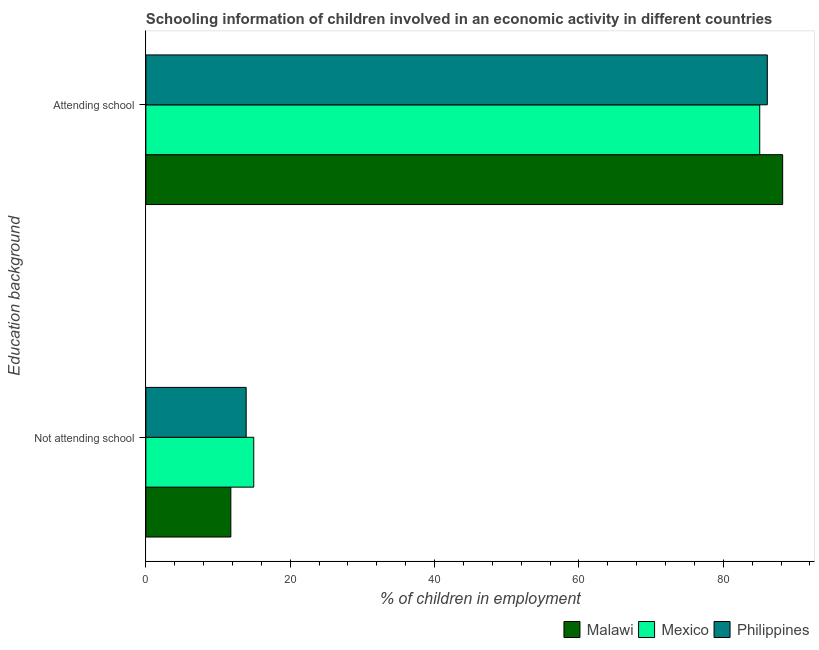How many bars are there on the 2nd tick from the bottom?
Provide a succinct answer. 3. What is the label of the 2nd group of bars from the top?
Provide a succinct answer. Not attending school. What is the percentage of employed children who are attending school in Philippines?
Your answer should be very brief. 86.1. Across all countries, what is the maximum percentage of employed children who are attending school?
Ensure brevity in your answer.  88.22. Across all countries, what is the minimum percentage of employed children who are not attending school?
Your answer should be compact. 11.78. In which country was the percentage of employed children who are attending school maximum?
Give a very brief answer. Malawi. In which country was the percentage of employed children who are not attending school minimum?
Ensure brevity in your answer.  Malawi. What is the total percentage of employed children who are not attending school in the graph?
Your response must be concise. 40.63. What is the difference between the percentage of employed children who are attending school in Philippines and that in Mexico?
Ensure brevity in your answer.  1.05. What is the difference between the percentage of employed children who are not attending school in Mexico and the percentage of employed children who are attending school in Malawi?
Offer a very short reply. -73.27. What is the average percentage of employed children who are attending school per country?
Your response must be concise. 86.46. What is the difference between the percentage of employed children who are attending school and percentage of employed children who are not attending school in Mexico?
Offer a very short reply. 70.1. In how many countries, is the percentage of employed children who are attending school greater than 56 %?
Provide a succinct answer. 3. What is the ratio of the percentage of employed children who are attending school in Malawi to that in Philippines?
Keep it short and to the point. 1.02. Is the percentage of employed children who are attending school in Malawi less than that in Mexico?
Provide a short and direct response. No. What does the 2nd bar from the top in Attending school represents?
Ensure brevity in your answer.  Mexico. What does the 1st bar from the bottom in Not attending school represents?
Ensure brevity in your answer.  Malawi. How many bars are there?
Provide a short and direct response. 6. What is the difference between two consecutive major ticks on the X-axis?
Offer a terse response. 20. Does the graph contain grids?
Offer a terse response. No. Where does the legend appear in the graph?
Your answer should be very brief. Bottom right. How are the legend labels stacked?
Provide a short and direct response. Horizontal. What is the title of the graph?
Provide a short and direct response. Schooling information of children involved in an economic activity in different countries. Does "Iran" appear as one of the legend labels in the graph?
Your response must be concise. No. What is the label or title of the X-axis?
Offer a very short reply. % of children in employment. What is the label or title of the Y-axis?
Ensure brevity in your answer.  Education background. What is the % of children in employment in Malawi in Not attending school?
Offer a terse response. 11.78. What is the % of children in employment of Mexico in Not attending school?
Offer a very short reply. 14.95. What is the % of children in employment of Malawi in Attending school?
Provide a short and direct response. 88.22. What is the % of children in employment of Mexico in Attending school?
Provide a succinct answer. 85.05. What is the % of children in employment in Philippines in Attending school?
Your answer should be very brief. 86.1. Across all Education background, what is the maximum % of children in employment of Malawi?
Offer a very short reply. 88.22. Across all Education background, what is the maximum % of children in employment of Mexico?
Keep it short and to the point. 85.05. Across all Education background, what is the maximum % of children in employment of Philippines?
Make the answer very short. 86.1. Across all Education background, what is the minimum % of children in employment of Malawi?
Your answer should be very brief. 11.78. Across all Education background, what is the minimum % of children in employment in Mexico?
Provide a succinct answer. 14.95. Across all Education background, what is the minimum % of children in employment in Philippines?
Provide a short and direct response. 13.9. What is the total % of children in employment in Malawi in the graph?
Provide a short and direct response. 100. What is the difference between the % of children in employment in Malawi in Not attending school and that in Attending school?
Your answer should be compact. -76.45. What is the difference between the % of children in employment of Mexico in Not attending school and that in Attending school?
Your response must be concise. -70.1. What is the difference between the % of children in employment of Philippines in Not attending school and that in Attending school?
Provide a short and direct response. -72.2. What is the difference between the % of children in employment of Malawi in Not attending school and the % of children in employment of Mexico in Attending school?
Your answer should be very brief. -73.27. What is the difference between the % of children in employment of Malawi in Not attending school and the % of children in employment of Philippines in Attending school?
Offer a terse response. -74.32. What is the difference between the % of children in employment in Mexico in Not attending school and the % of children in employment in Philippines in Attending school?
Keep it short and to the point. -71.15. What is the average % of children in employment in Malawi per Education background?
Make the answer very short. 50. What is the average % of children in employment of Mexico per Education background?
Provide a short and direct response. 50. What is the average % of children in employment of Philippines per Education background?
Make the answer very short. 50. What is the difference between the % of children in employment of Malawi and % of children in employment of Mexico in Not attending school?
Ensure brevity in your answer.  -3.17. What is the difference between the % of children in employment of Malawi and % of children in employment of Philippines in Not attending school?
Offer a very short reply. -2.12. What is the difference between the % of children in employment in Mexico and % of children in employment in Philippines in Not attending school?
Keep it short and to the point. 1.05. What is the difference between the % of children in employment in Malawi and % of children in employment in Mexico in Attending school?
Give a very brief answer. 3.17. What is the difference between the % of children in employment of Malawi and % of children in employment of Philippines in Attending school?
Provide a succinct answer. 2.12. What is the difference between the % of children in employment of Mexico and % of children in employment of Philippines in Attending school?
Keep it short and to the point. -1.05. What is the ratio of the % of children in employment in Malawi in Not attending school to that in Attending school?
Give a very brief answer. 0.13. What is the ratio of the % of children in employment of Mexico in Not attending school to that in Attending school?
Your answer should be very brief. 0.18. What is the ratio of the % of children in employment in Philippines in Not attending school to that in Attending school?
Offer a terse response. 0.16. What is the difference between the highest and the second highest % of children in employment in Malawi?
Give a very brief answer. 76.45. What is the difference between the highest and the second highest % of children in employment in Mexico?
Give a very brief answer. 70.1. What is the difference between the highest and the second highest % of children in employment of Philippines?
Offer a terse response. 72.2. What is the difference between the highest and the lowest % of children in employment in Malawi?
Provide a short and direct response. 76.45. What is the difference between the highest and the lowest % of children in employment of Mexico?
Your response must be concise. 70.1. What is the difference between the highest and the lowest % of children in employment in Philippines?
Offer a terse response. 72.2. 